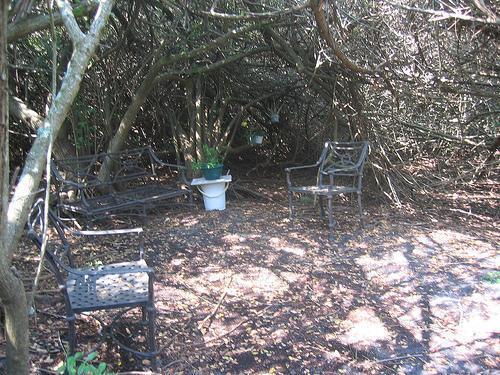How many people could sit on the bench?
Give a very brief answer. 2. 